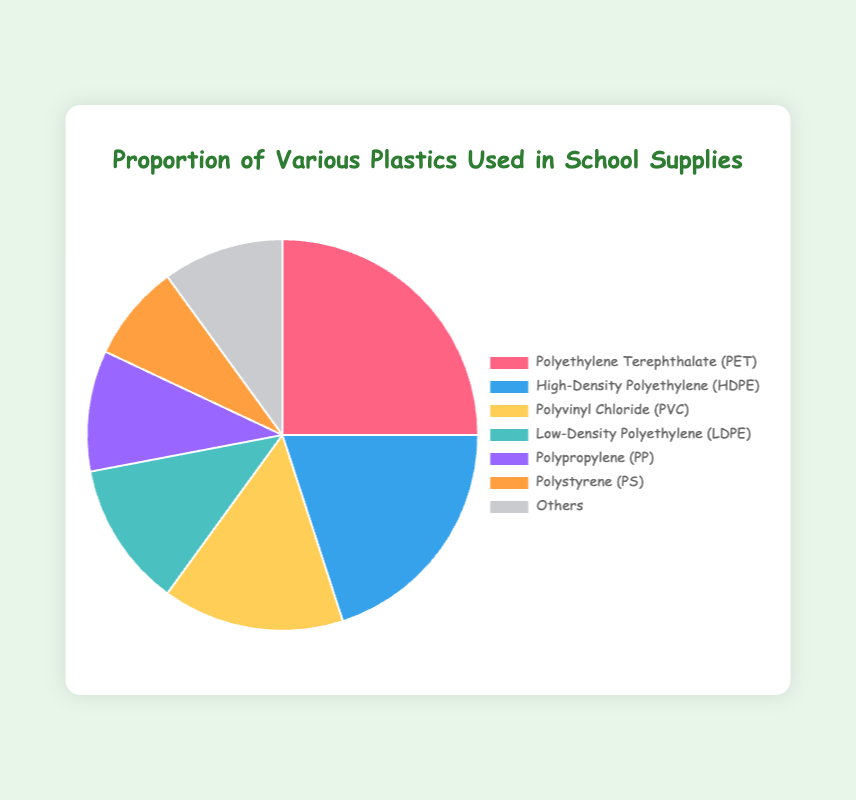What is the most commonly used type of plastic in school supplies? Look at the pie chart and identify the plastic type with the largest segment, marked as "Polyethylene Terephthalate (PET)" at 25%.
Answer: Polyethylene Terephthalate (PET) Which type of plastic has a higher usage percentage: HDPE or LDPE? Compare the usage percentages of High-Density Polyethylene (HDPE) and Low-Density Polyethylene (LDPE) in the chart: HDPE has 20%, and LDPE has 12%.
Answer: High-Density Polyethylene (HDPE) What is the combined usage percentage of Polypropylene (PP) and Polystyrene (PS)? Add the usage percentages of Polypropylene (PP) at 10% and Polystyrene (PS) at 8%. The sum is 10% + 8% = 18%.
Answer: 18% Which plastic type has the smallest usage percentage, and what is it? Identify the smallest segment in the pie chart, marked as "Polystyrene (PS)" at 8%.
Answer: Polystyrene (PS), 8% If the total usage of plastics needs to be reduced by 10%, what would be the new percentage of usage for High-Density Polyethylene (HDPE) alone? Subtract 10% (reduction factor) from the current HDPE usage of 20%. Calculated as 20% - 10% of 20% = 20% - 2% = 18%.
Answer: 18% Is the usage of Polyvinyl Chloride (PVC) more or less than a quarter of the total usage? Compare the usage percentage of Polyvinyl Chloride (PVC) at 15% to a quarter (25%) of the total. It's less than 25%.
Answer: Less What is the difference in usage percentage between the most and least used plastics? Subtract the usage percentage of the least used plastic (Polystyrene (PS) at 8%) from the most used plastic (Polyethylene Terephthalate (PET) at 25%). 25% - 8% is 17%.
Answer: 17% How many types of plastics have a usage percentage above 10%? Count the segments in the pie chart with a usage percentage above 10%: PET (25%), HDPE (20%), PVC (15%), and LDPE (12%). There are 4 such types.
Answer: 4 